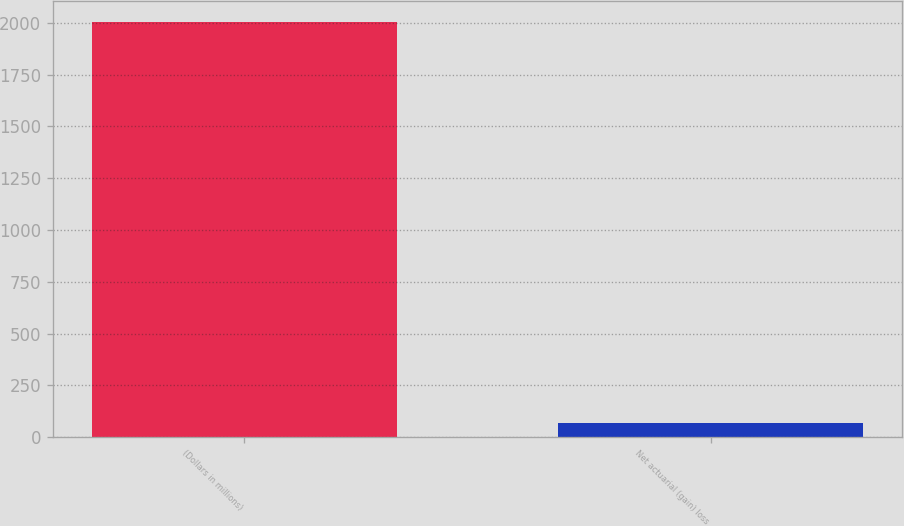Convert chart. <chart><loc_0><loc_0><loc_500><loc_500><bar_chart><fcel>(Dollars in millions)<fcel>Net actuarial (gain) loss<nl><fcel>2006<fcel>68<nl></chart> 